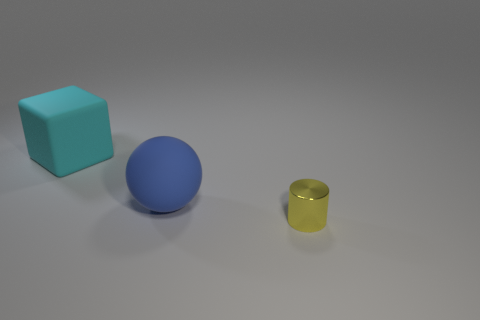Add 1 big blue spheres. How many objects exist? 4 Subtract all balls. How many objects are left? 2 Add 2 big blue balls. How many big blue balls exist? 3 Subtract 0 brown blocks. How many objects are left? 3 Subtract all purple metallic things. Subtract all cyan rubber objects. How many objects are left? 2 Add 1 large cyan things. How many large cyan things are left? 2 